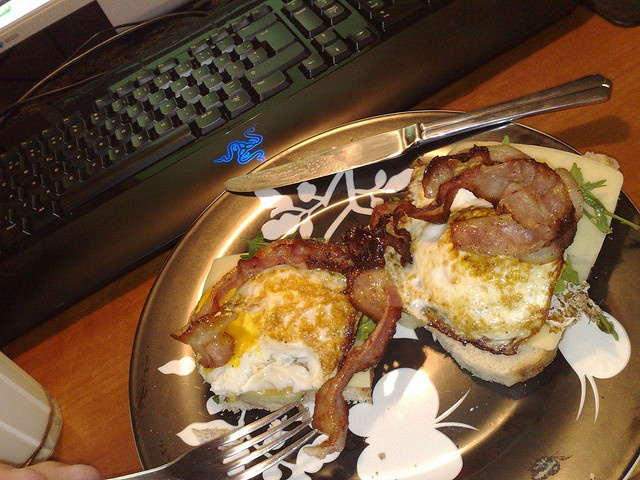Describe the objects in this image and their specific colors. I can see keyboard in gray, black, maroon, and darkgreen tones, sandwich in gray, brown, maroon, and tan tones, sandwich in gray, brown, orange, and tan tones, knife in gray, maroon, and tan tones, and cup in gray, tan, darkgray, and brown tones in this image. 